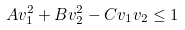<formula> <loc_0><loc_0><loc_500><loc_500>A v _ { 1 } ^ { 2 } + B v _ { 2 } ^ { 2 } - C v _ { 1 } v _ { 2 } \leq 1</formula> 